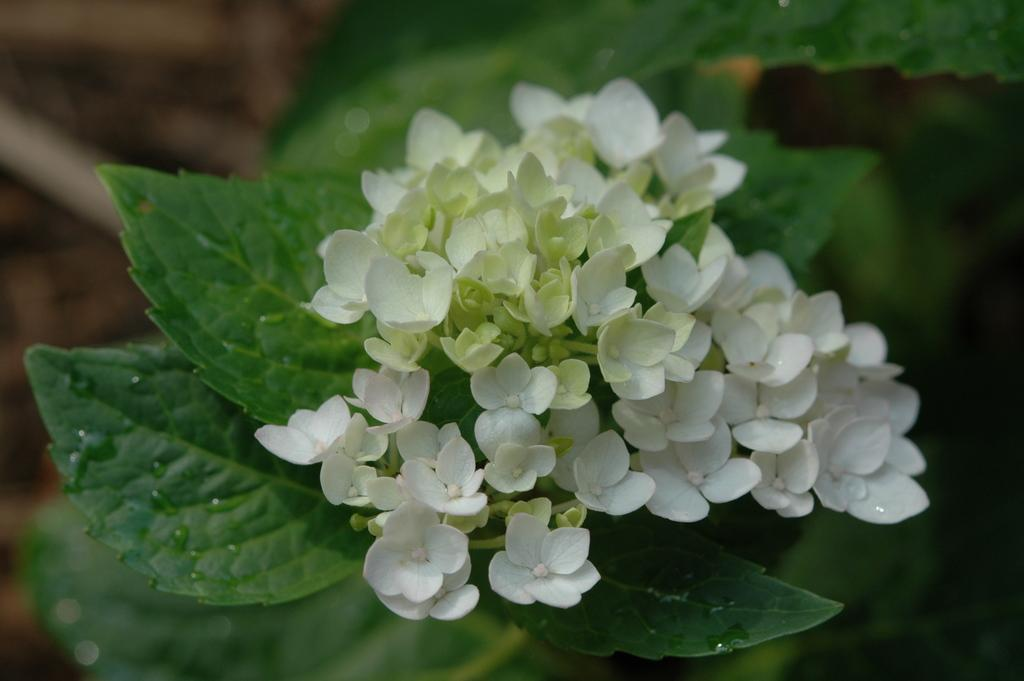What color are the flowers in the image? The flowers in the image are white. What color are the leaves in the image? The leaves in the image are green. Can you describe the background of the image? The background of the image is blurred. What type of beef is being used to cover the flowers in the image? There is no beef present in the image, and the flowers are not being covered by anything. 